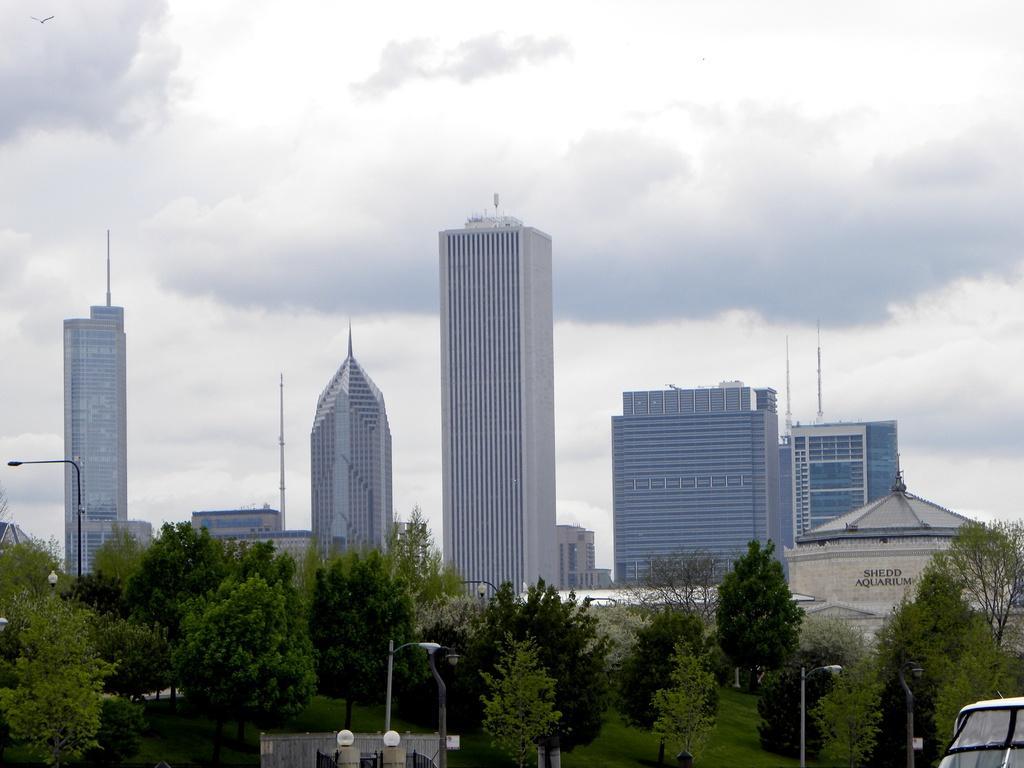Can you describe this image briefly? There are some poles at the bottom of this image, and trees are present in the background. There are some buildings as we can see in the middle of this image, and there is a cloudy sky at the top of this image. It seems like there is a vehicle at the bottom right corner of this image. 